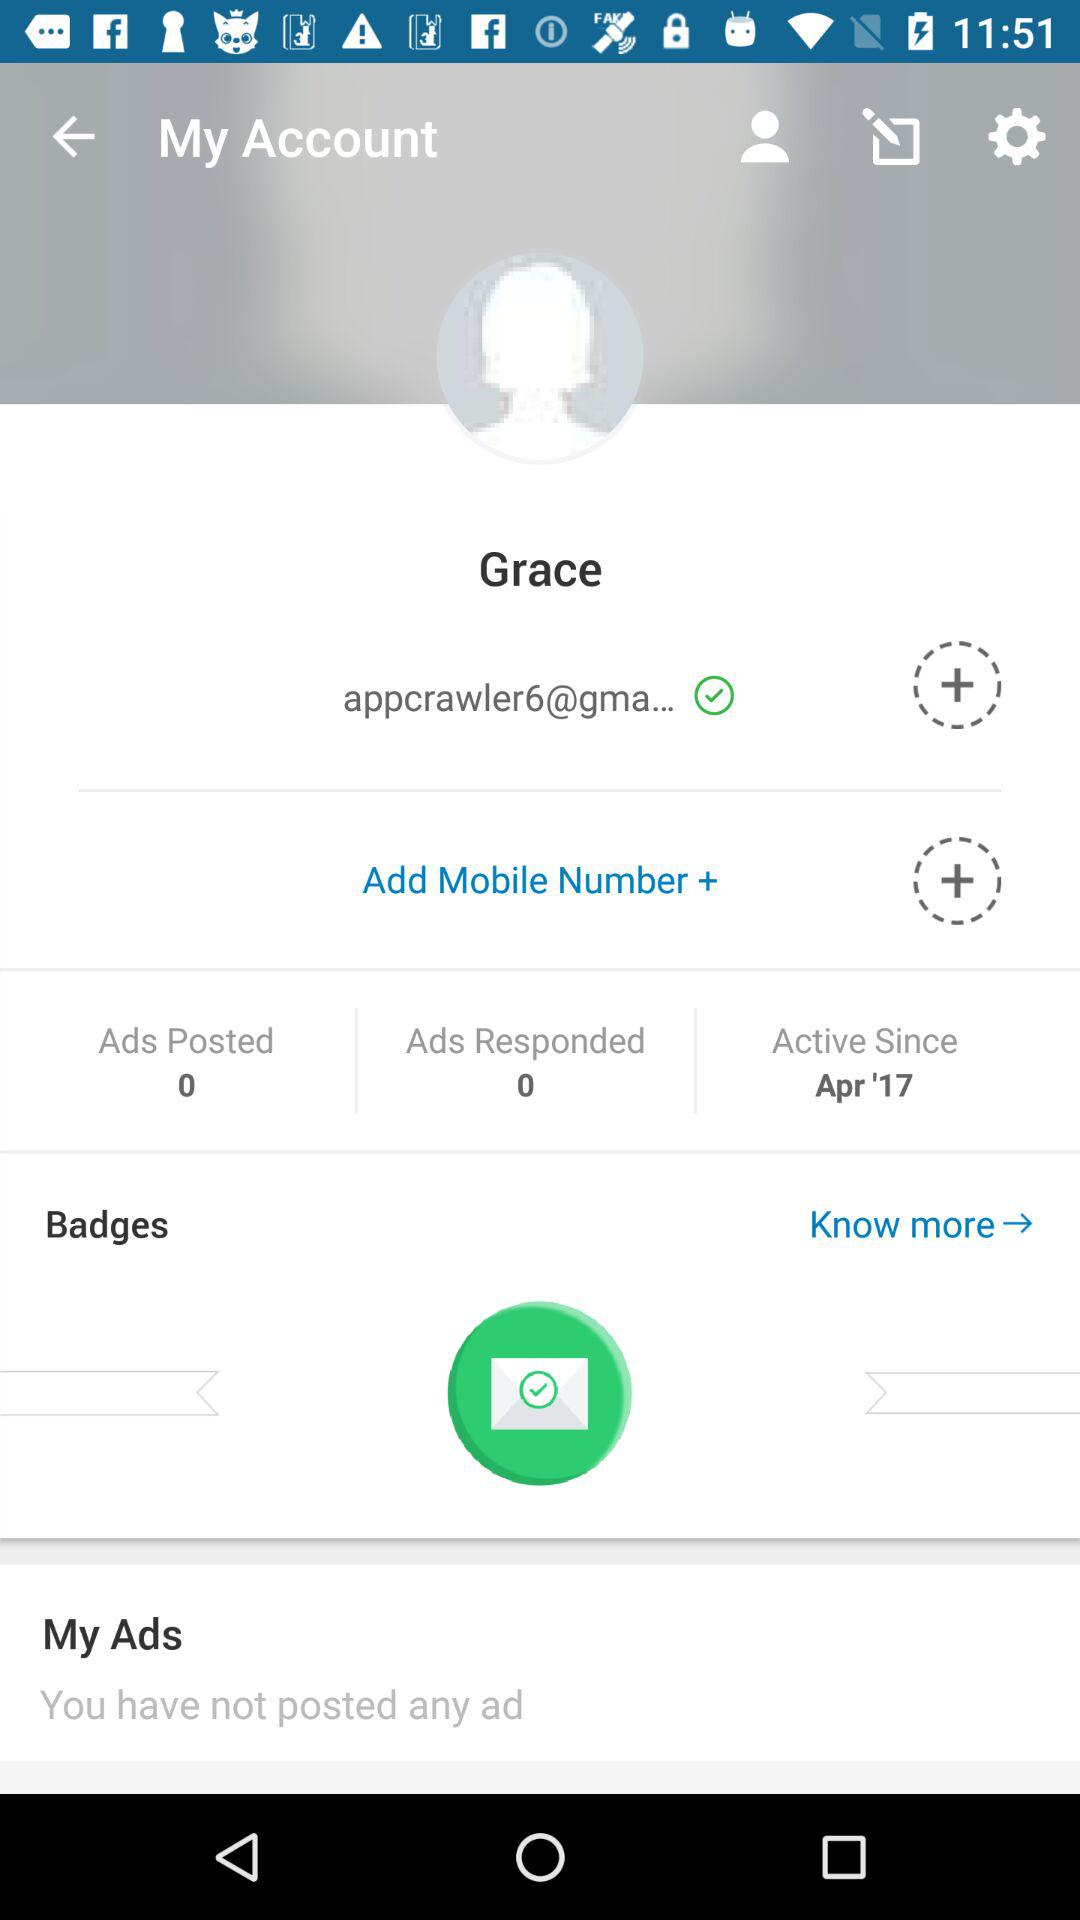Is there an ad posted in "My Ads"? There is no ad posted in "My Ads". 